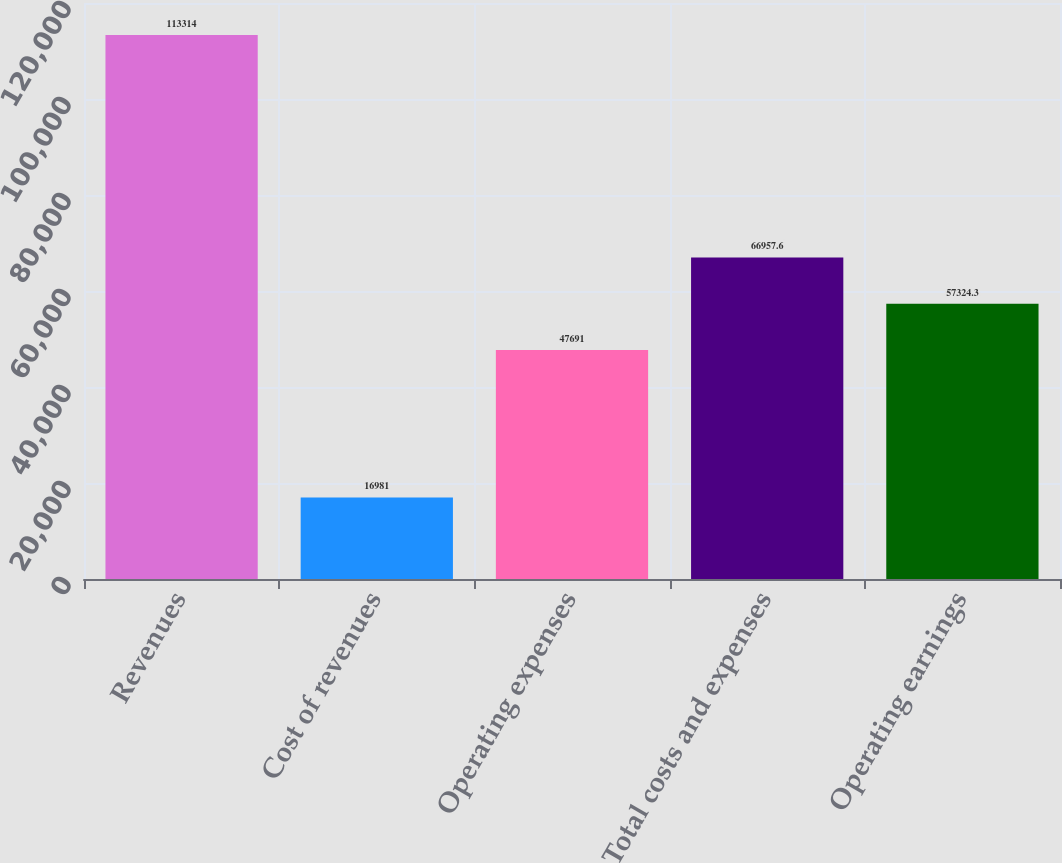Convert chart to OTSL. <chart><loc_0><loc_0><loc_500><loc_500><bar_chart><fcel>Revenues<fcel>Cost of revenues<fcel>Operating expenses<fcel>Total costs and expenses<fcel>Operating earnings<nl><fcel>113314<fcel>16981<fcel>47691<fcel>66957.6<fcel>57324.3<nl></chart> 